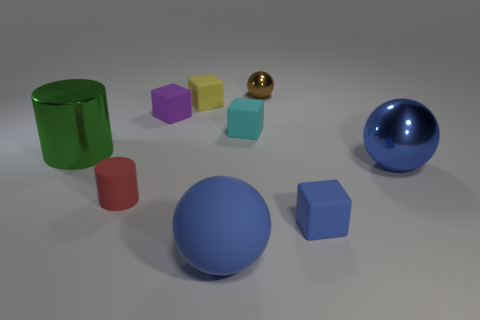There is another ball that is the same color as the large shiny sphere; what is its size?
Provide a succinct answer. Large. Are there any large shiny spheres of the same color as the large rubber sphere?
Provide a succinct answer. Yes. Are there any other things of the same color as the matte ball?
Make the answer very short. Yes. There is a matte thing that is the same color as the matte sphere; what is its shape?
Your answer should be very brief. Cube. Do the small rubber thing that is to the right of the tiny cyan rubber cube and the big rubber object have the same color?
Offer a very short reply. Yes. Do the big rubber thing and the large metallic sphere have the same color?
Provide a short and direct response. Yes. How many red cylinders have the same material as the cyan cube?
Offer a terse response. 1. The large object that is the same material as the tiny red thing is what color?
Ensure brevity in your answer.  Blue. The green metallic thing has what shape?
Provide a succinct answer. Cylinder. What number of cubes are the same color as the big metal ball?
Offer a very short reply. 1. 